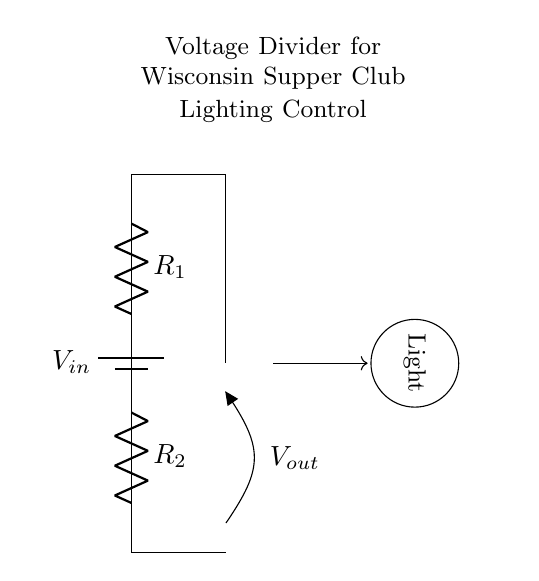What is the input voltage in this circuit? The input voltage is labeled as V in the circuit diagram, representing the voltage provided by the battery in the system.
Answer: V in What are the two resistors in the circuit? The resistors are labeled R1 and R2 in the circuit diagram, which are used to create the voltage divider effect.
Answer: R1 and R2 What does V out represent in the circuit? V out represents the output voltage at the junction between the two resistors, which is used to control the brightness of the light.
Answer: Output voltage What will happen if R2 is increased? Increasing R2 will result in a higher output voltage V out, which means the light will become brighter as more voltage is supplied to it.
Answer: Light gets brighter What is the function of the voltage divider in this circuit? The function of the voltage divider is to reduce the input voltage to a lower output voltage that can be used to dim the lighting in the supper club.
Answer: To control dimming How does the arrangement of resistors affect the output voltage? The output voltage is determined by the ratio of the resistances of R1 and R2; specifically, it can be calculated using the formula V out = V in * (R2 / (R1 + R2)). A different arrangement of resistors leads to different output voltages.
Answer: It affects output voltage ratio How does the light symbol relate to the voltage divider? The light symbol indicates that the output voltage V out is connected to a lighting system, meaning the output voltage from the voltage divider controls the light brightness.
Answer: Controls light brightness 